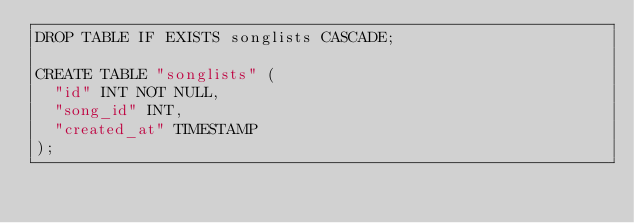Convert code to text. <code><loc_0><loc_0><loc_500><loc_500><_SQL_>DROP TABLE IF EXISTS songlists CASCADE;

CREATE TABLE "songlists" (
  "id" INT NOT NULL,
  "song_id" INT,
  "created_at" TIMESTAMP
);</code> 